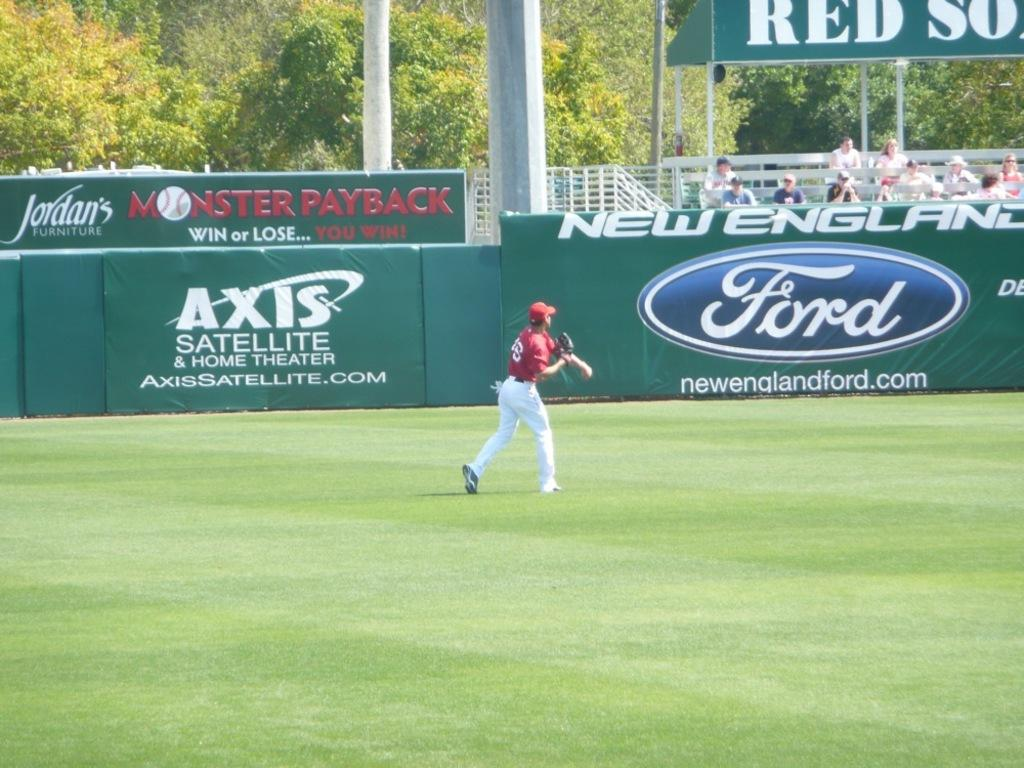<image>
Render a clear and concise summary of the photo. A baseball player in a red top throws the ball in front of advertising boards for Ford, Axis Satelite and Jordans. 